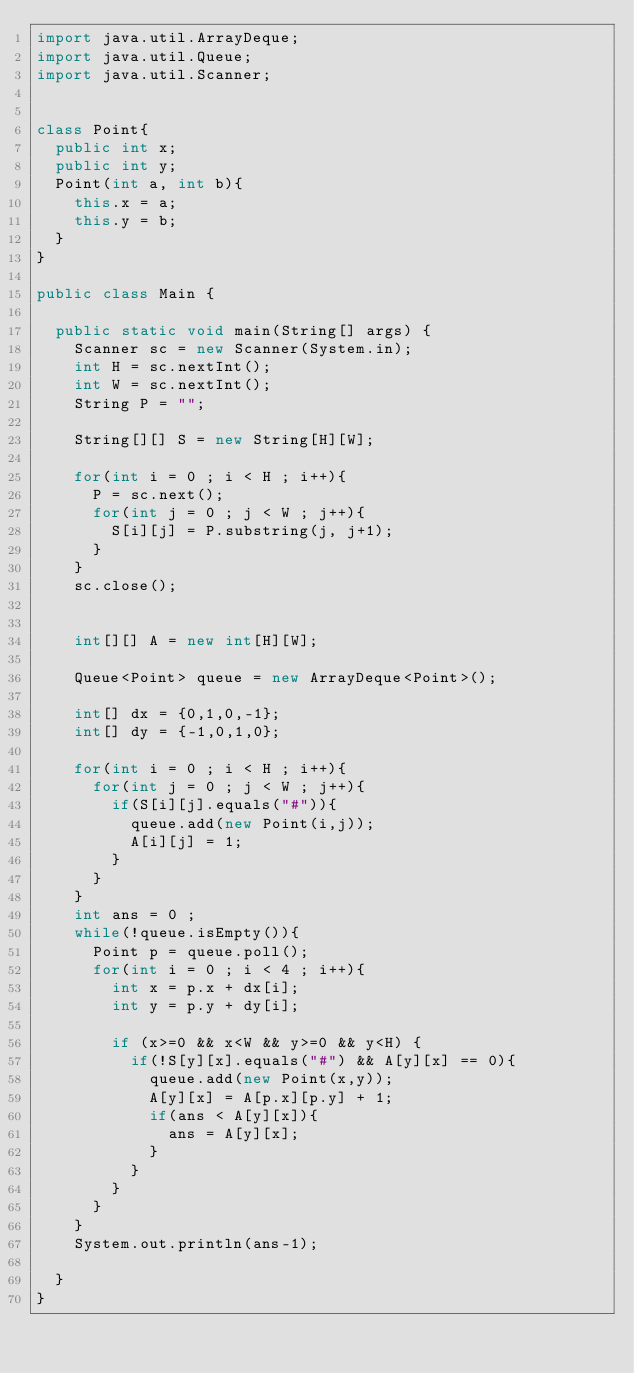<code> <loc_0><loc_0><loc_500><loc_500><_Java_>import java.util.ArrayDeque;
import java.util.Queue;
import java.util.Scanner;


class Point{
	public int x;
	public int y;
	Point(int a, int b){
		this.x = a;
		this.y = b;
	}
}

public class Main {

	public static void main(String[] args) {
		Scanner sc = new Scanner(System.in);
		int H = sc.nextInt();
		int W = sc.nextInt();
		String P = "";

		String[][] S = new String[H][W];

		for(int i = 0 ; i < H ; i++){
			P = sc.next();
			for(int j = 0 ; j < W ; j++){
				S[i][j] = P.substring(j, j+1);
			}
		}
		sc.close();


		int[][] A = new int[H][W];

		Queue<Point> queue = new ArrayDeque<Point>();

		int[] dx = {0,1,0,-1};
		int[] dy = {-1,0,1,0};

		for(int i = 0 ; i < H ; i++){
			for(int j = 0 ; j < W ; j++){
				if(S[i][j].equals("#")){
					queue.add(new Point(i,j));
					A[i][j] = 1;
				}
			}
		}
		int ans = 0 ;
		while(!queue.isEmpty()){
			Point p = queue.poll();
			for(int i = 0 ; i < 4 ; i++){
				int x = p.x + dx[i];
				int y = p.y + dy[i];

				if (x>=0 && x<W && y>=0 && y<H) {
					if(!S[y][x].equals("#") && A[y][x] == 0){
						queue.add(new Point(x,y));
						A[y][x] = A[p.x][p.y] + 1;
						if(ans < A[y][x]){
							ans = A[y][x];
						}
					}
				}
			}
		}
		System.out.println(ans-1);

	}
}
</code> 